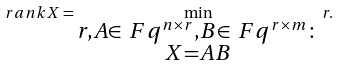Convert formula to latex. <formula><loc_0><loc_0><loc_500><loc_500>\ r a n k X = \min _ { \substack { r , A \in \ F q ^ { n \times r } , B \in \ F q ^ { r \times m } \colon \\ X = A B } } r .</formula> 